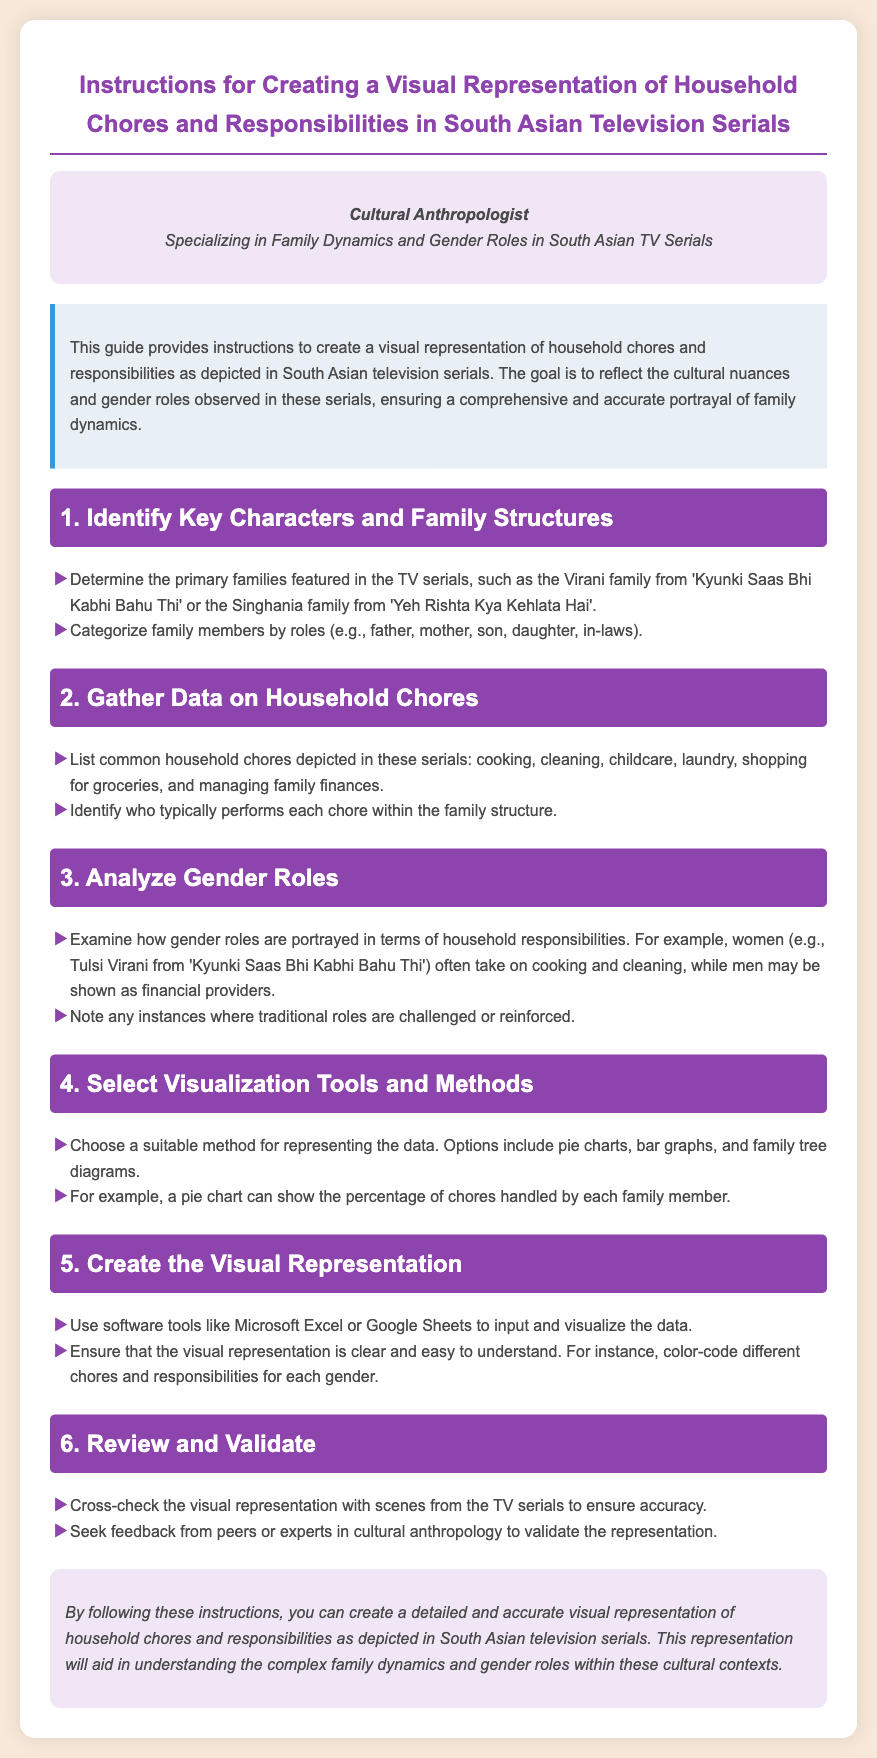what is the title of the document? The title is stated in the header section of the document.
Answer: Instructions for Creating a Visual Representation of Household Chores and Responsibilities in South Asian Television Serials who is the intended audience for the document? The intended audience is specified in the header, indicating the professional focus.
Answer: Cultural Anthropologist what is the first step in creating the visual representation? The first step is outlined in the first section of the instructions.
Answer: Identify Key Characters and Family Structures which family is mentioned as an example in the document? The document provides specific examples of families featured in South Asian TV serials.
Answer: Virani family what types of visualization tools are suggested? The document outlines the options for tools in one of the sections.
Answer: Microsoft Excel or Google Sheets how many sections are included in the document? The number of sections can be counted from the main content.
Answer: Six what is emphasized in the analysis of gender roles? The document specifies an important aspect regarding the roles in household responsibilities.
Answer: Cooking and cleaning what should be done in the review phase? The document describes the actions to be taken during the review step.
Answer: Cross-check the visual representation with scenes from the TV serials what should be color-coded in the visualization? The document suggests how to differentiate in the visual representation.
Answer: Different chores and responsibilities for each gender 